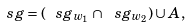<formula> <loc_0><loc_0><loc_500><loc_500>\ s g = ( \ s g _ { w _ { 1 } } \cap \ s g _ { w _ { 2 } } ) \cup A ,</formula> 